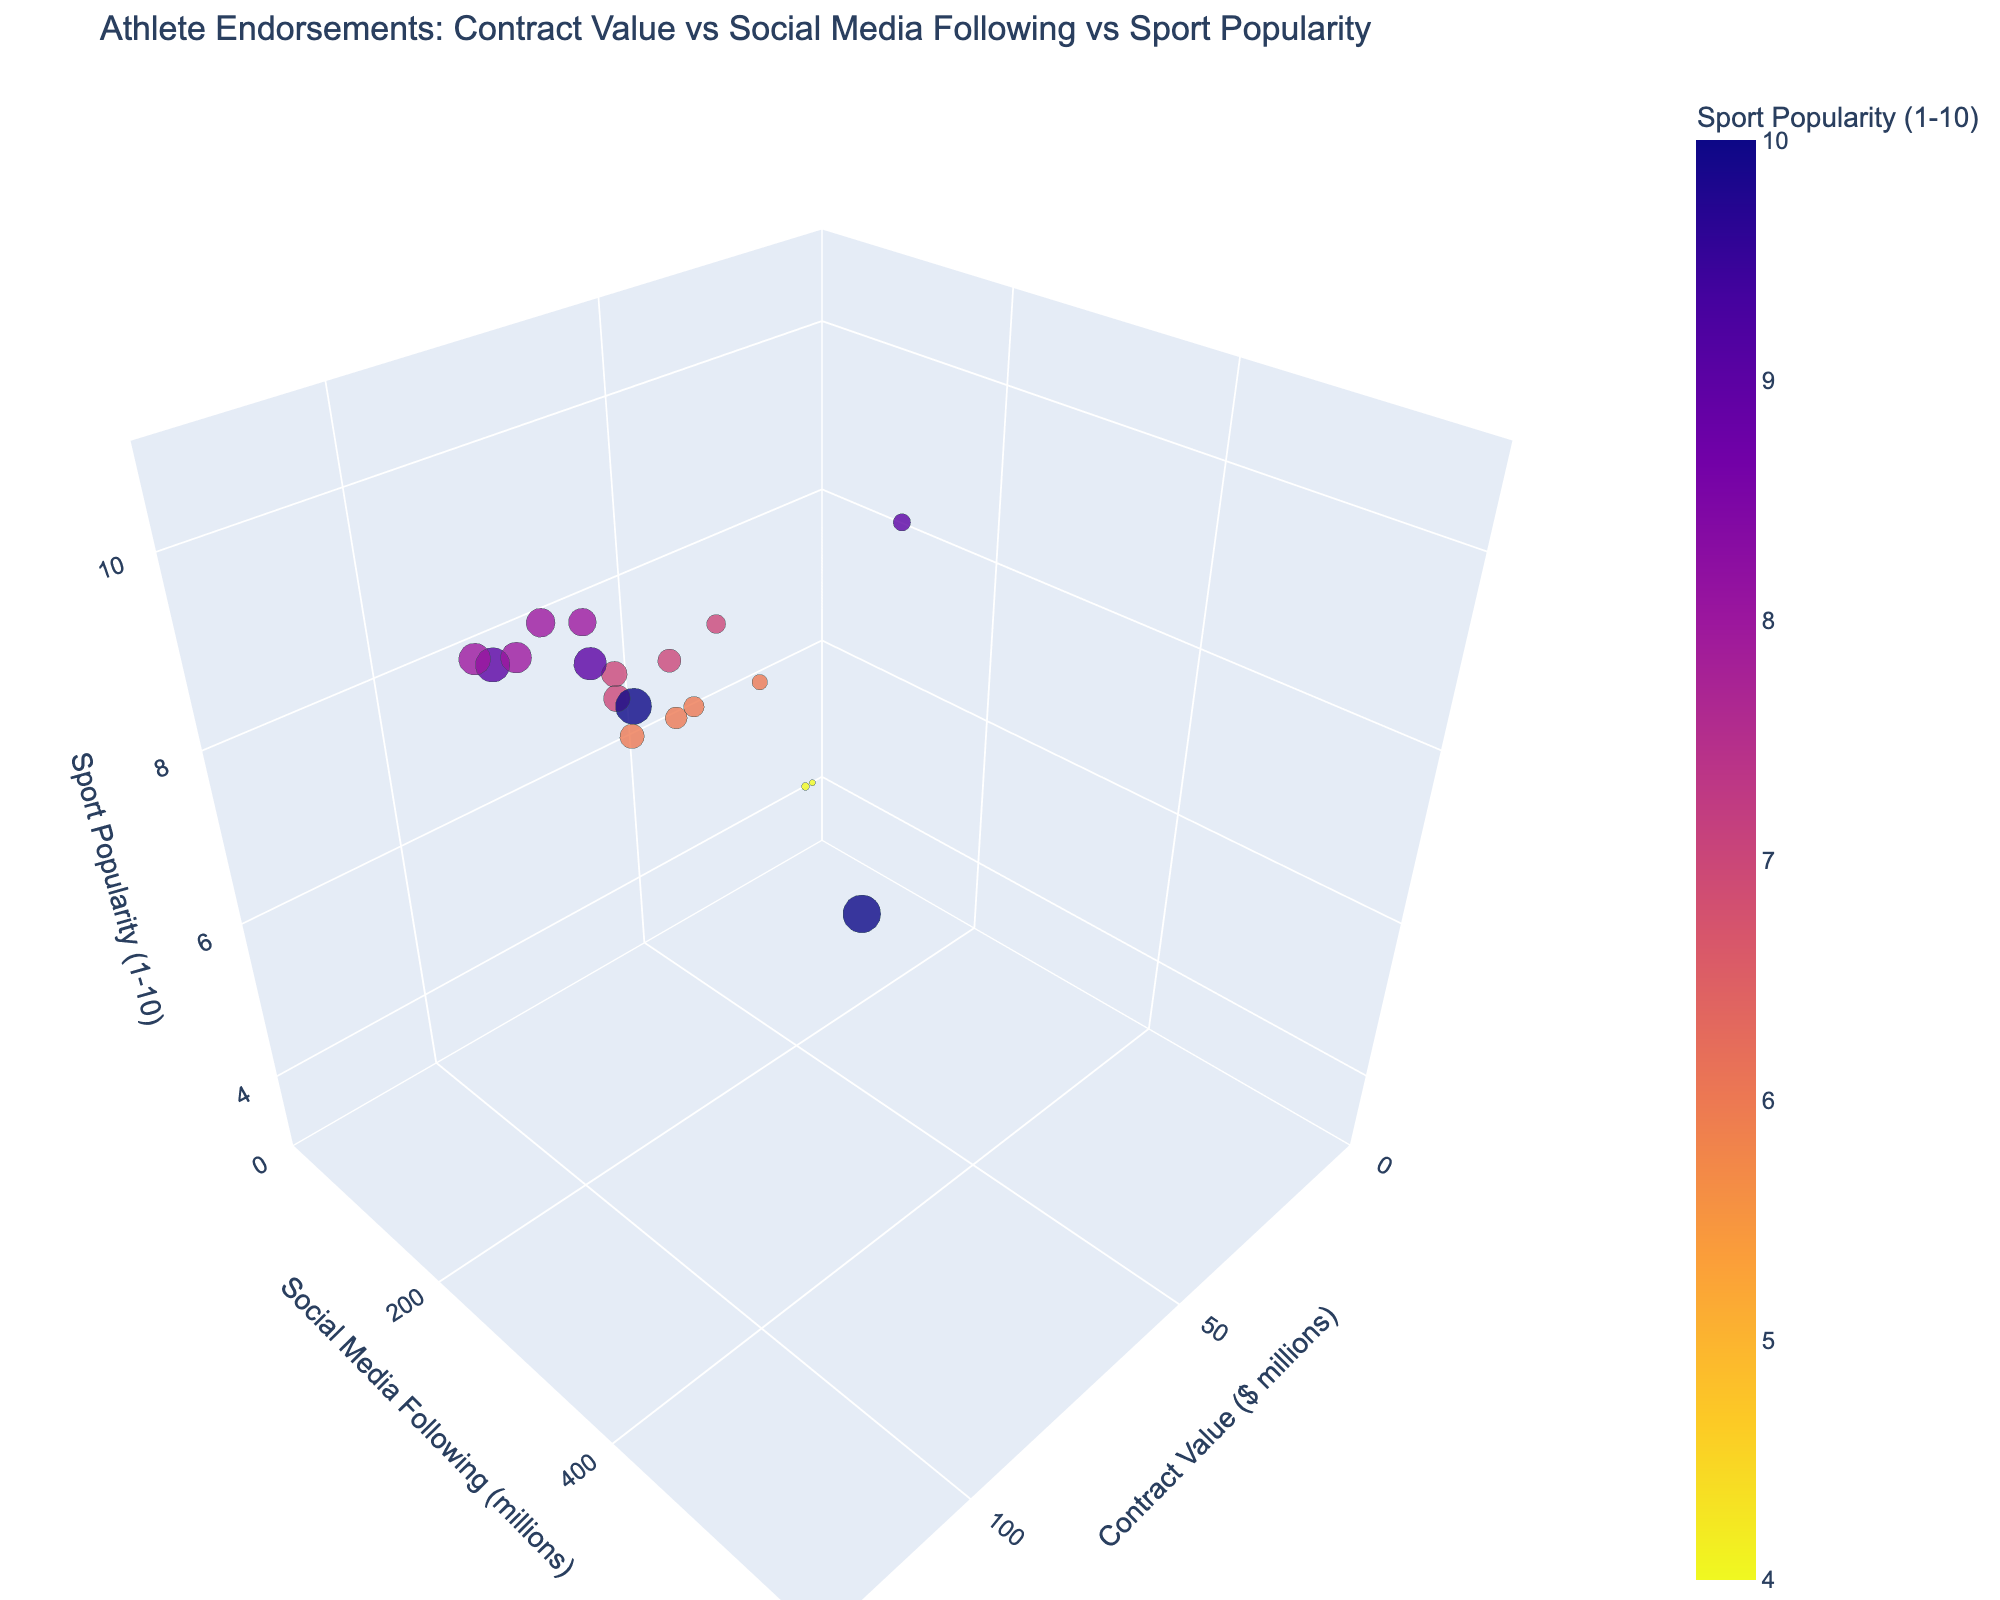How many athletes have a contract value over $100 million? First, locate the axis representing the contract value and identify the points plotted above the $100 million mark. Count the total number of these points to find the number of athletes with a contract value over $100 million. There are two such points: Cristiano Ronaldo and Lionel Messi.
Answer: 2 Which athlete has the highest social media following? To find this, look for the point furthest along the social media following axis. The highest point represents the athlete with the largest following. Cristiano Ronaldo is positioned farthest along the axis with 580 million followers.
Answer: Cristiano Ronaldo Which sport has athletes with the highest contract values in general? Observe the distribution of points along the contract value axis and which sport they are associated with. Soccer athletes like Cristiano Ronaldo, Lionel Messi, and Neymar Jr. are positioned towards the higher end of the contract value axis, indicating that soccer generally has the highest contract values among the plotted athletes.
Answer: Soccer Who has a higher contract value, Roger Federer or Rafael Nadal? Locate the points for Roger Federer and Rafael Nadal and compare their positions along the contract value axis. Roger Federer is positioned at $85 million, whereas Rafael Nadal is at $65 million. Thus, Roger Federer has a higher contract value.
Answer: Roger Federer What is the average social media following of athletes with a contract value above $80 million? Identify athletes with contracts above $80 million (LeBron James, Cristiano Ronaldo, Neymar Jr., Lionel Messi, Stephen Curry, Roger Federer). Sum their social media followings (156 + 580 + 200 + 360 + 48 + 28 = 1372 million). Divide the total social media following by the number of athletes (1372 / 6). The average social media following is approximately 228.67 million.
Answer: 228.67 million How does Serena Williams' social media following compare to Simone Biles'? Find the positions of Serena Williams and Simone Biles along the social media following axis. Serena Williams has 15 million followers, while Simone Biles has 7 million followers, indicating that Serena Williams has a higher social media following.
Answer: Serena Williams What is the sport popularity rating for athletes with the lowest contract values? Identify the athletes with the lowest contract values (Phil Ivey and Daniel Negreanu). Both have a contract value of $5 million or below and belong to poker. According to the plot, they both have a sport popularity rating of 4.
Answer: 4 Which athlete stands out the most in terms of contract value and social media following combination? Look for an outlier point in terms of both high contract value and high social media following. Cristiano Ronaldo, with a $120 million contract and 580 million followers, stands out the most in both respects.
Answer: Cristiano Ronaldo Compare the contract values for athletes in tennis. Identify the tennis players (Serena Williams, Roger Federer, Rafael Nadal, Naomi Osaka). Compare their positions along the contract value axis: Roger Federer ($85 million), Rafael Nadal ($65 million), Serena Williams ($55 million), Naomi Osaka ($50 million). Therefore, Roger Federer has the highest contract value among the tennis players listed.
Answer: Roger Federer 